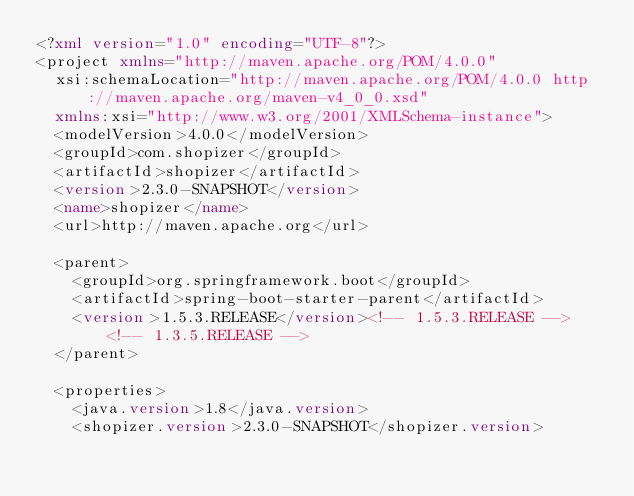<code> <loc_0><loc_0><loc_500><loc_500><_XML_><?xml version="1.0" encoding="UTF-8"?>
<project xmlns="http://maven.apache.org/POM/4.0.0"
	xsi:schemaLocation="http://maven.apache.org/POM/4.0.0 http://maven.apache.org/maven-v4_0_0.xsd"
	xmlns:xsi="http://www.w3.org/2001/XMLSchema-instance">
	<modelVersion>4.0.0</modelVersion>
	<groupId>com.shopizer</groupId>
	<artifactId>shopizer</artifactId>
	<version>2.3.0-SNAPSHOT</version>
	<name>shopizer</name>
	<url>http://maven.apache.org</url>

	<parent>
		<groupId>org.springframework.boot</groupId>
		<artifactId>spring-boot-starter-parent</artifactId>
		<version>1.5.3.RELEASE</version><!-- 1.5.3.RELEASE --> <!-- 1.3.5.RELEASE -->
	</parent>

	<properties>
		<java.version>1.8</java.version>
		<shopizer.version>2.3.0-SNAPSHOT</shopizer.version></code> 